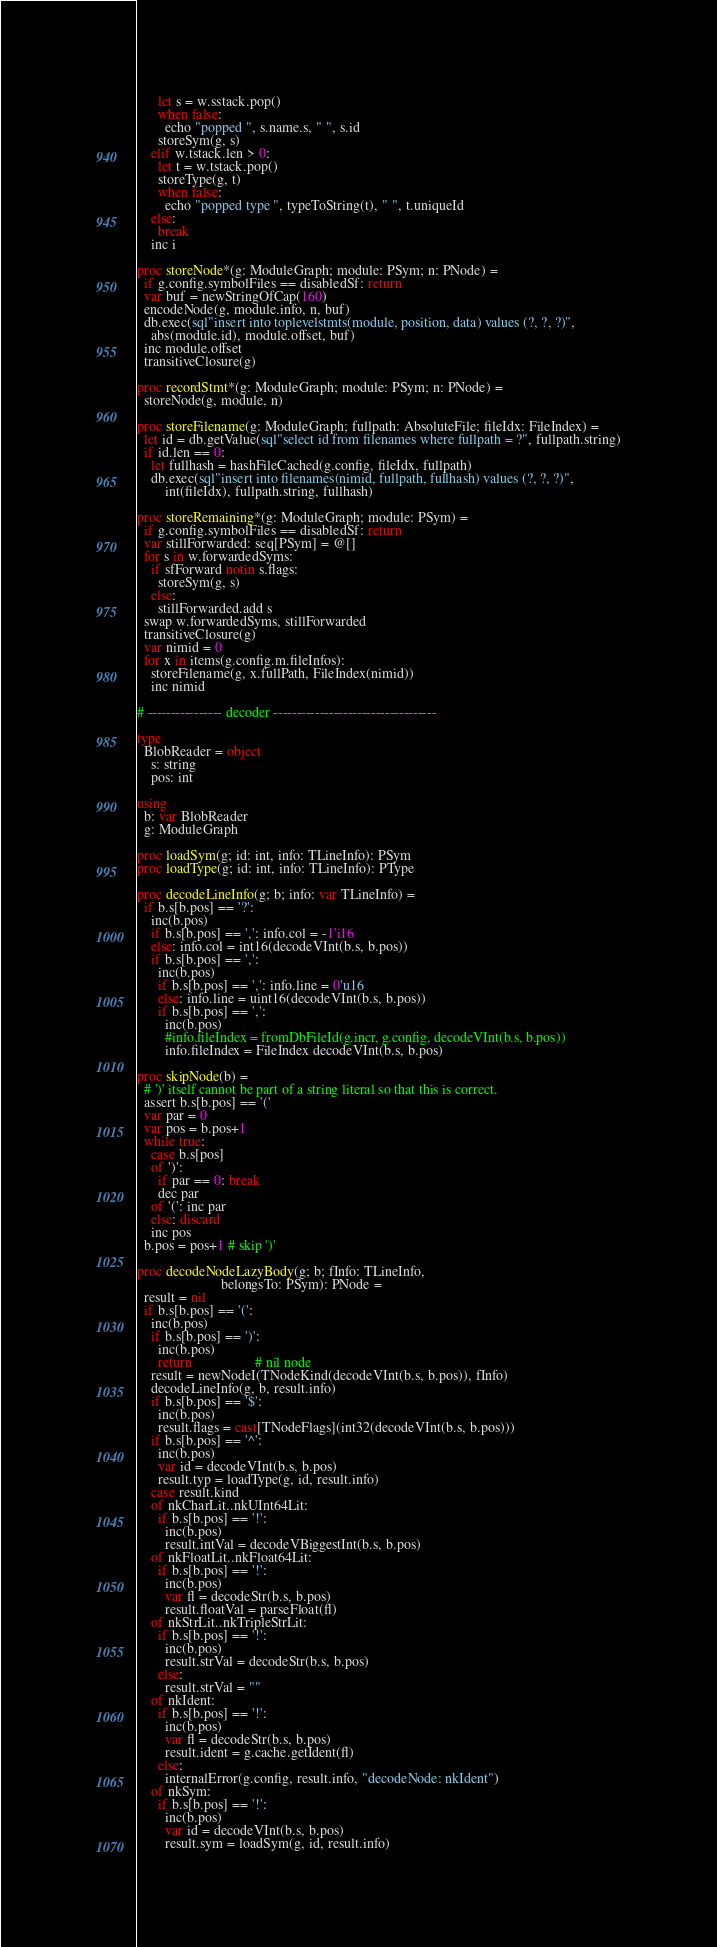Convert code to text. <code><loc_0><loc_0><loc_500><loc_500><_Nim_>      let s = w.sstack.pop()
      when false:
        echo "popped ", s.name.s, " ", s.id
      storeSym(g, s)
    elif w.tstack.len > 0:
      let t = w.tstack.pop()
      storeType(g, t)
      when false:
        echo "popped type ", typeToString(t), " ", t.uniqueId
    else:
      break
    inc i

proc storeNode*(g: ModuleGraph; module: PSym; n: PNode) =
  if g.config.symbolFiles == disabledSf: return
  var buf = newStringOfCap(160)
  encodeNode(g, module.info, n, buf)
  db.exec(sql"insert into toplevelstmts(module, position, data) values (?, ?, ?)",
    abs(module.id), module.offset, buf)
  inc module.offset
  transitiveClosure(g)

proc recordStmt*(g: ModuleGraph; module: PSym; n: PNode) =
  storeNode(g, module, n)

proc storeFilename(g: ModuleGraph; fullpath: AbsoluteFile; fileIdx: FileIndex) =
  let id = db.getValue(sql"select id from filenames where fullpath = ?", fullpath.string)
  if id.len == 0:
    let fullhash = hashFileCached(g.config, fileIdx, fullpath)
    db.exec(sql"insert into filenames(nimid, fullpath, fullhash) values (?, ?, ?)",
        int(fileIdx), fullpath.string, fullhash)

proc storeRemaining*(g: ModuleGraph; module: PSym) =
  if g.config.symbolFiles == disabledSf: return
  var stillForwarded: seq[PSym] = @[]
  for s in w.forwardedSyms:
    if sfForward notin s.flags:
      storeSym(g, s)
    else:
      stillForwarded.add s
  swap w.forwardedSyms, stillForwarded
  transitiveClosure(g)
  var nimid = 0
  for x in items(g.config.m.fileInfos):
    storeFilename(g, x.fullPath, FileIndex(nimid))
    inc nimid

# ---------------- decoder -----------------------------------

type
  BlobReader = object
    s: string
    pos: int

using
  b: var BlobReader
  g: ModuleGraph

proc loadSym(g; id: int, info: TLineInfo): PSym
proc loadType(g; id: int, info: TLineInfo): PType

proc decodeLineInfo(g; b; info: var TLineInfo) =
  if b.s[b.pos] == '?':
    inc(b.pos)
    if b.s[b.pos] == ',': info.col = -1'i16
    else: info.col = int16(decodeVInt(b.s, b.pos))
    if b.s[b.pos] == ',':
      inc(b.pos)
      if b.s[b.pos] == ',': info.line = 0'u16
      else: info.line = uint16(decodeVInt(b.s, b.pos))
      if b.s[b.pos] == ',':
        inc(b.pos)
        #info.fileIndex = fromDbFileId(g.incr, g.config, decodeVInt(b.s, b.pos))
        info.fileIndex = FileIndex decodeVInt(b.s, b.pos)

proc skipNode(b) =
  # ')' itself cannot be part of a string literal so that this is correct.
  assert b.s[b.pos] == '('
  var par = 0
  var pos = b.pos+1
  while true:
    case b.s[pos]
    of ')':
      if par == 0: break
      dec par
    of '(': inc par
    else: discard
    inc pos
  b.pos = pos+1 # skip ')'

proc decodeNodeLazyBody(g; b; fInfo: TLineInfo,
                        belongsTo: PSym): PNode =
  result = nil
  if b.s[b.pos] == '(':
    inc(b.pos)
    if b.s[b.pos] == ')':
      inc(b.pos)
      return                  # nil node
    result = newNodeI(TNodeKind(decodeVInt(b.s, b.pos)), fInfo)
    decodeLineInfo(g, b, result.info)
    if b.s[b.pos] == '$':
      inc(b.pos)
      result.flags = cast[TNodeFlags](int32(decodeVInt(b.s, b.pos)))
    if b.s[b.pos] == '^':
      inc(b.pos)
      var id = decodeVInt(b.s, b.pos)
      result.typ = loadType(g, id, result.info)
    case result.kind
    of nkCharLit..nkUInt64Lit:
      if b.s[b.pos] == '!':
        inc(b.pos)
        result.intVal = decodeVBiggestInt(b.s, b.pos)
    of nkFloatLit..nkFloat64Lit:
      if b.s[b.pos] == '!':
        inc(b.pos)
        var fl = decodeStr(b.s, b.pos)
        result.floatVal = parseFloat(fl)
    of nkStrLit..nkTripleStrLit:
      if b.s[b.pos] == '!':
        inc(b.pos)
        result.strVal = decodeStr(b.s, b.pos)
      else:
        result.strVal = ""
    of nkIdent:
      if b.s[b.pos] == '!':
        inc(b.pos)
        var fl = decodeStr(b.s, b.pos)
        result.ident = g.cache.getIdent(fl)
      else:
        internalError(g.config, result.info, "decodeNode: nkIdent")
    of nkSym:
      if b.s[b.pos] == '!':
        inc(b.pos)
        var id = decodeVInt(b.s, b.pos)
        result.sym = loadSym(g, id, result.info)</code> 